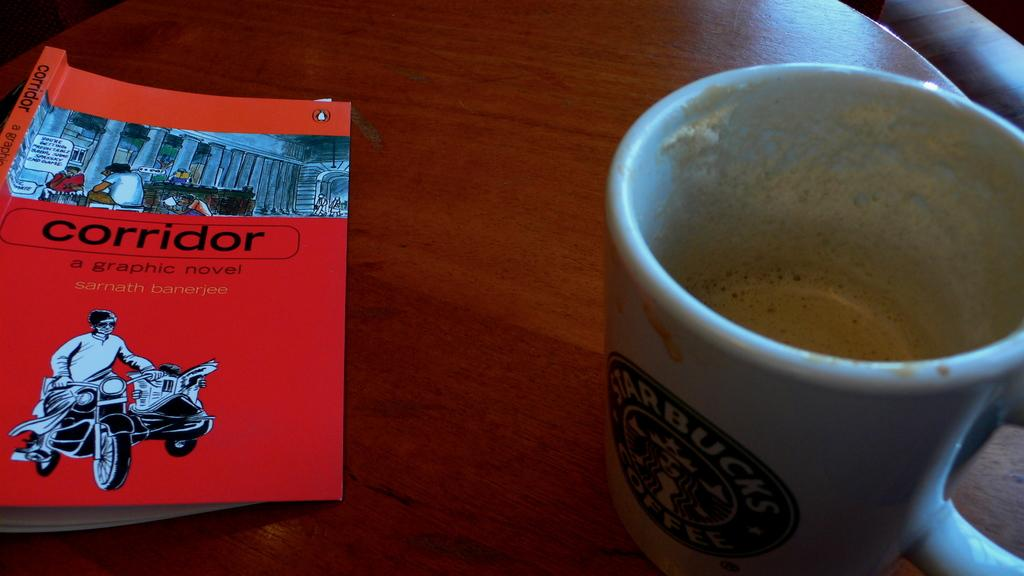<image>
Give a short and clear explanation of the subsequent image. A white ceramic Starbucks coffee mug with very little cappuccino in it sits on a table next to an orange book. 